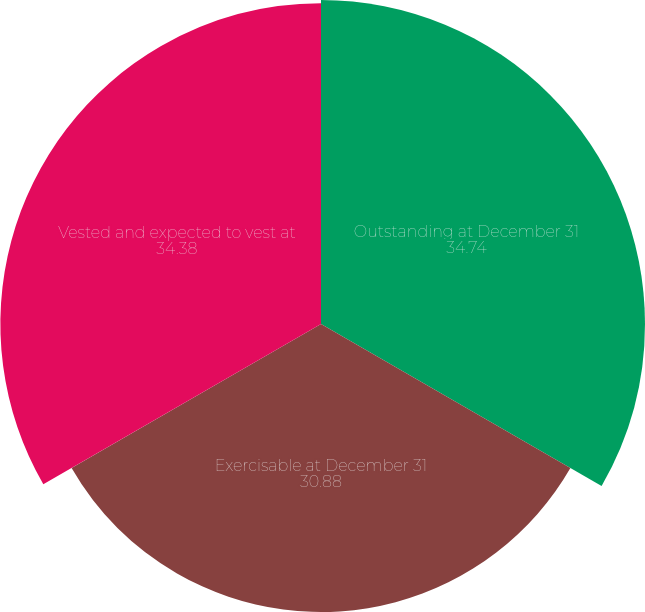Convert chart. <chart><loc_0><loc_0><loc_500><loc_500><pie_chart><fcel>Outstanding at December 31<fcel>Exercisable at December 31<fcel>Vested and expected to vest at<nl><fcel>34.74%<fcel>30.88%<fcel>34.38%<nl></chart> 